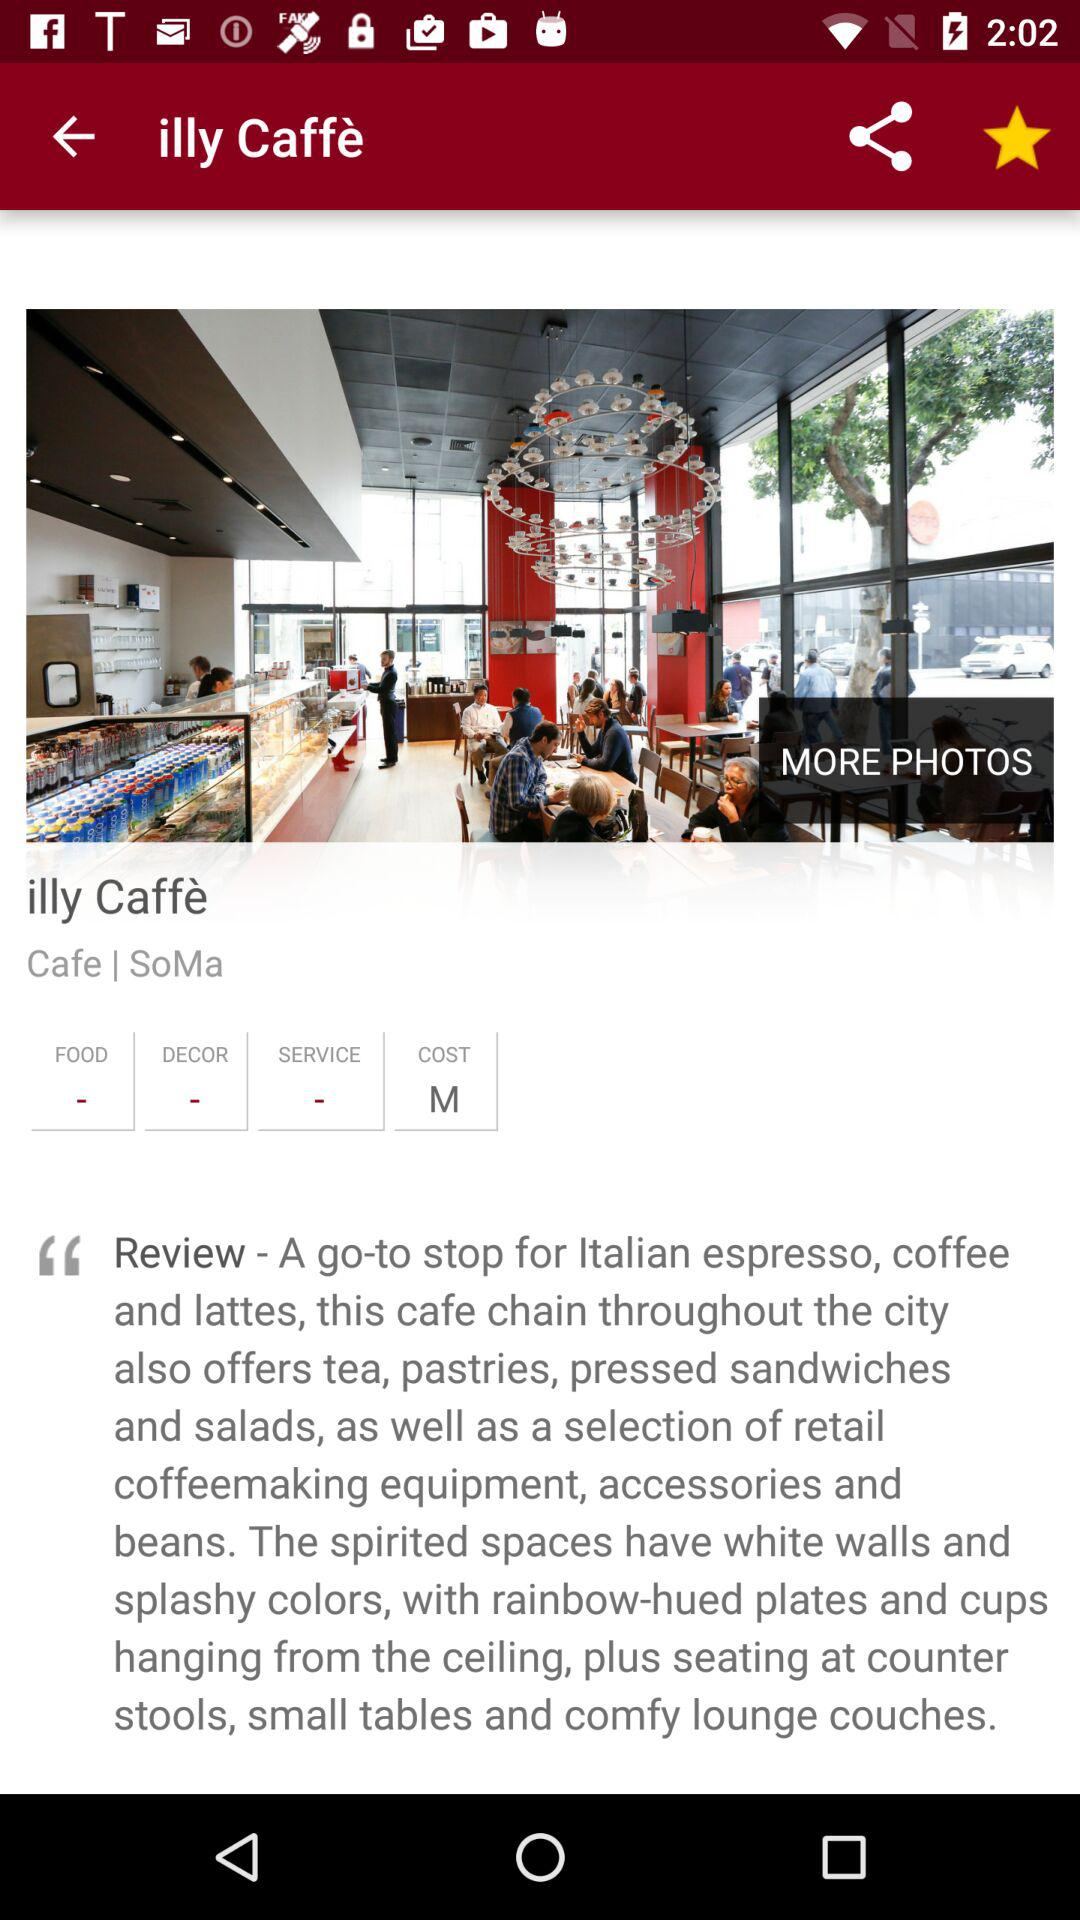What is the cost? The cost is M. 